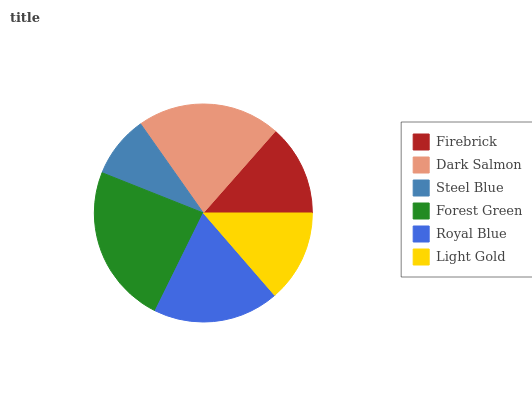Is Steel Blue the minimum?
Answer yes or no. Yes. Is Forest Green the maximum?
Answer yes or no. Yes. Is Dark Salmon the minimum?
Answer yes or no. No. Is Dark Salmon the maximum?
Answer yes or no. No. Is Dark Salmon greater than Firebrick?
Answer yes or no. Yes. Is Firebrick less than Dark Salmon?
Answer yes or no. Yes. Is Firebrick greater than Dark Salmon?
Answer yes or no. No. Is Dark Salmon less than Firebrick?
Answer yes or no. No. Is Royal Blue the high median?
Answer yes or no. Yes. Is Light Gold the low median?
Answer yes or no. Yes. Is Light Gold the high median?
Answer yes or no. No. Is Forest Green the low median?
Answer yes or no. No. 